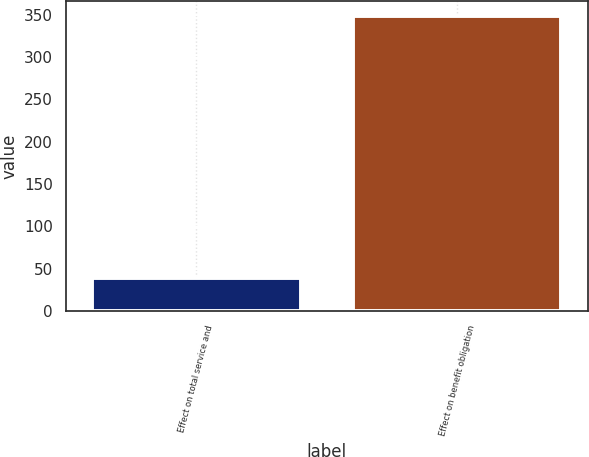Convert chart to OTSL. <chart><loc_0><loc_0><loc_500><loc_500><bar_chart><fcel>Effect on total service and<fcel>Effect on benefit obligation<nl><fcel>39<fcel>349<nl></chart> 